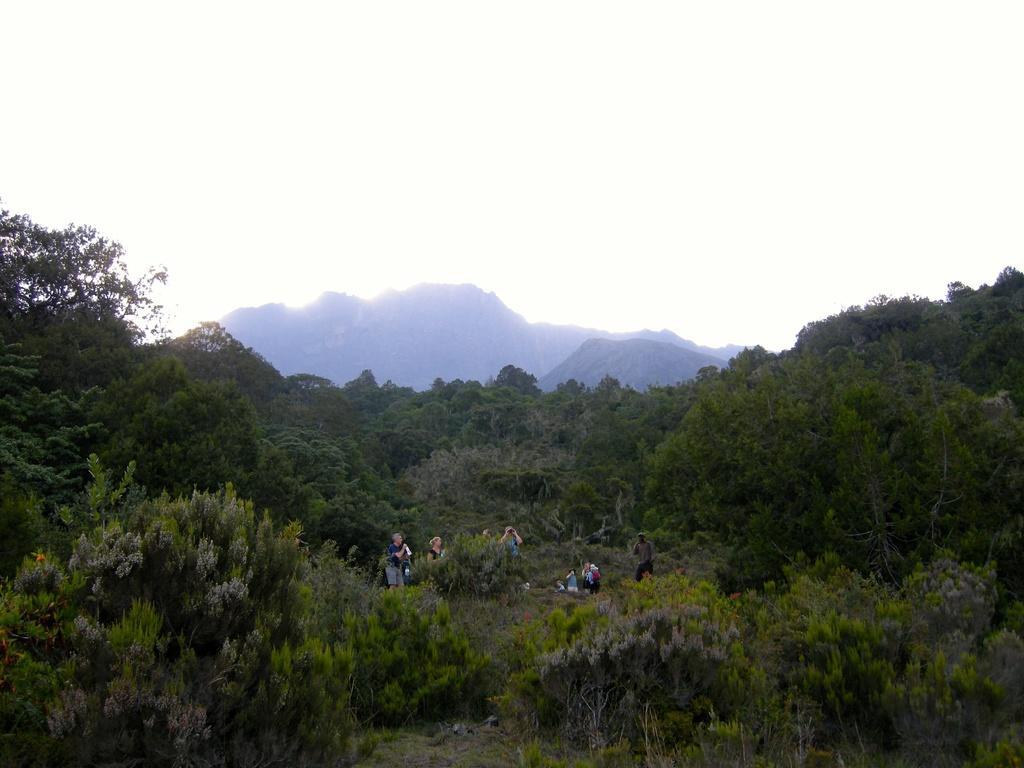Could you give a brief overview of what you see in this image? This is a forest area, this people came here to visit the forest. This is a sky which is in dark white color. 